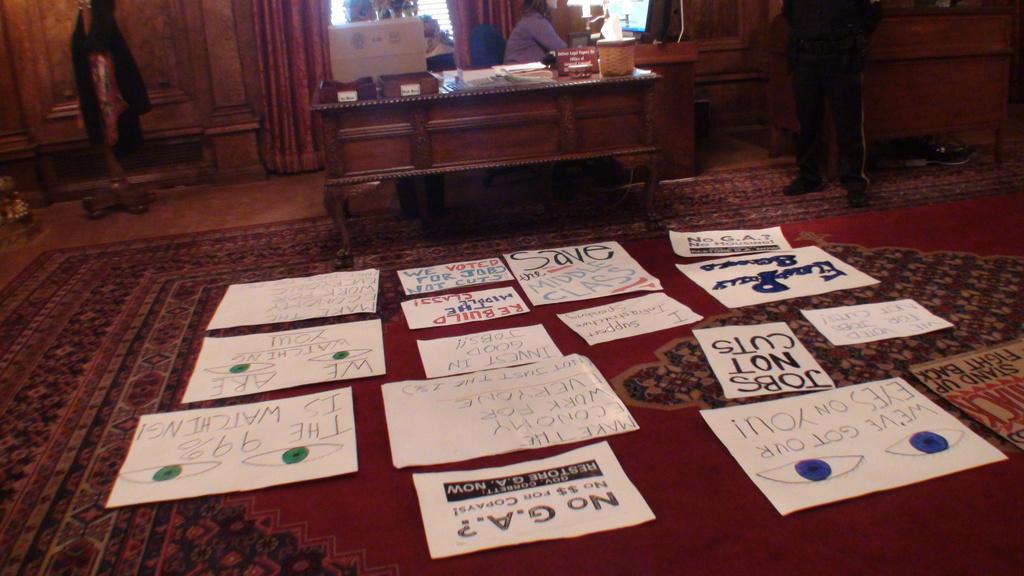Please provide a concise description of this image. As we can see in the image there is a table and few papers on floor and a mat. 